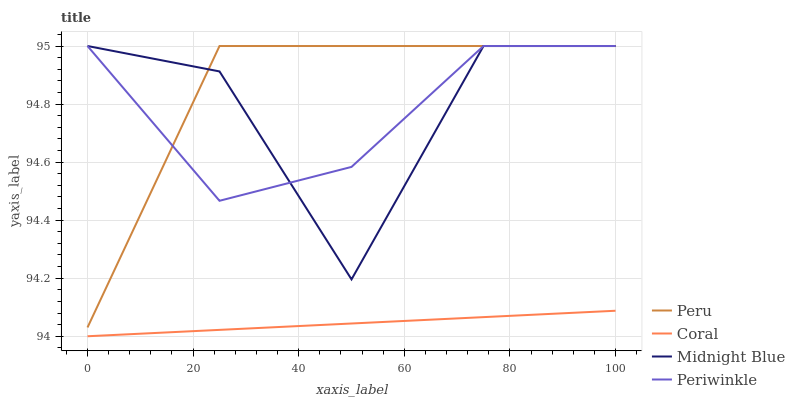Does Periwinkle have the minimum area under the curve?
Answer yes or no. No. Does Periwinkle have the maximum area under the curve?
Answer yes or no. No. Is Periwinkle the smoothest?
Answer yes or no. No. Is Periwinkle the roughest?
Answer yes or no. No. Does Midnight Blue have the lowest value?
Answer yes or no. No. Is Coral less than Peru?
Answer yes or no. Yes. Is Periwinkle greater than Coral?
Answer yes or no. Yes. Does Coral intersect Peru?
Answer yes or no. No. 